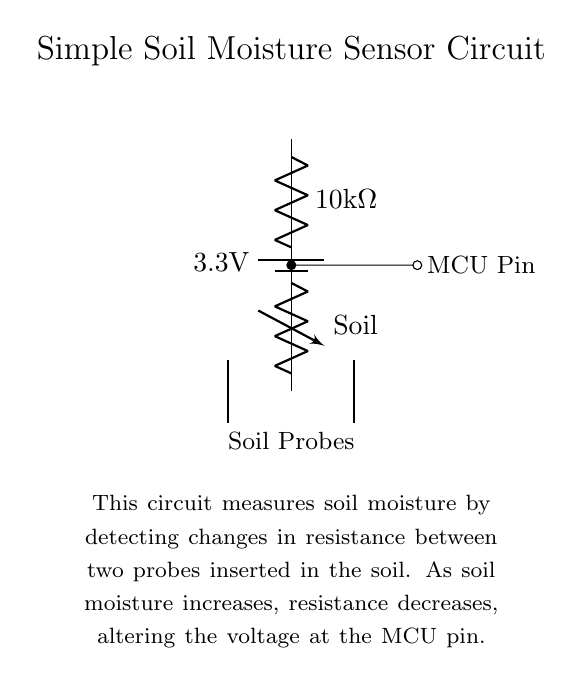What is the voltage of the battery in this circuit? The circuit has a battery labeled with a voltage of 3.3 volts. The battery supplies the necessary voltage for the sensor circuit to operate.
Answer: 3.3 volts What type of resistor is used in the voltage divider? The circuit shows a resistor labeled as 10 kilo-ohms. This resistor is part of the voltage divider configuration that helps determine the voltage at the microcontroller pin based on the soil resistance.
Answer: 10 kilo-ohms What kind of component connects to the microcontroller pin? The component connected to the microcontroller pin is a variable resistor, which represents the resistance change due to varying soil moisture levels. This variable resistance affects the voltage perceived by the microcontroller.
Answer: Variable resistor How does soil moisture affect the resistance in this circuit? The circuit operates on the principle that increased soil moisture decreases the resistance between the soil probes. When the soil is wet, the electrical conductivity increases, lowering the overall resistance and altering the voltage at the microcontroller pin, which can be detected.
Answer: Decreases What role do the soil probes play in this circuit? The soil probes serve as the points where moisture is measured by detecting the resistance in the soil. They are fundamental to the functioning of the sensor circuit because they create a resistance path that changes with soil moisture levels.
Answer: Measure moisture What happens to the voltage at the MCU pin when the soil is dry? When the soil is dry, the resistance between the probes increases, which causes the voltage at the microcontroller pin to also increase. This is because higher resistance results in less current flow through the voltage divider, affecting the voltage output detected by the microcontroller.
Answer: Increases 